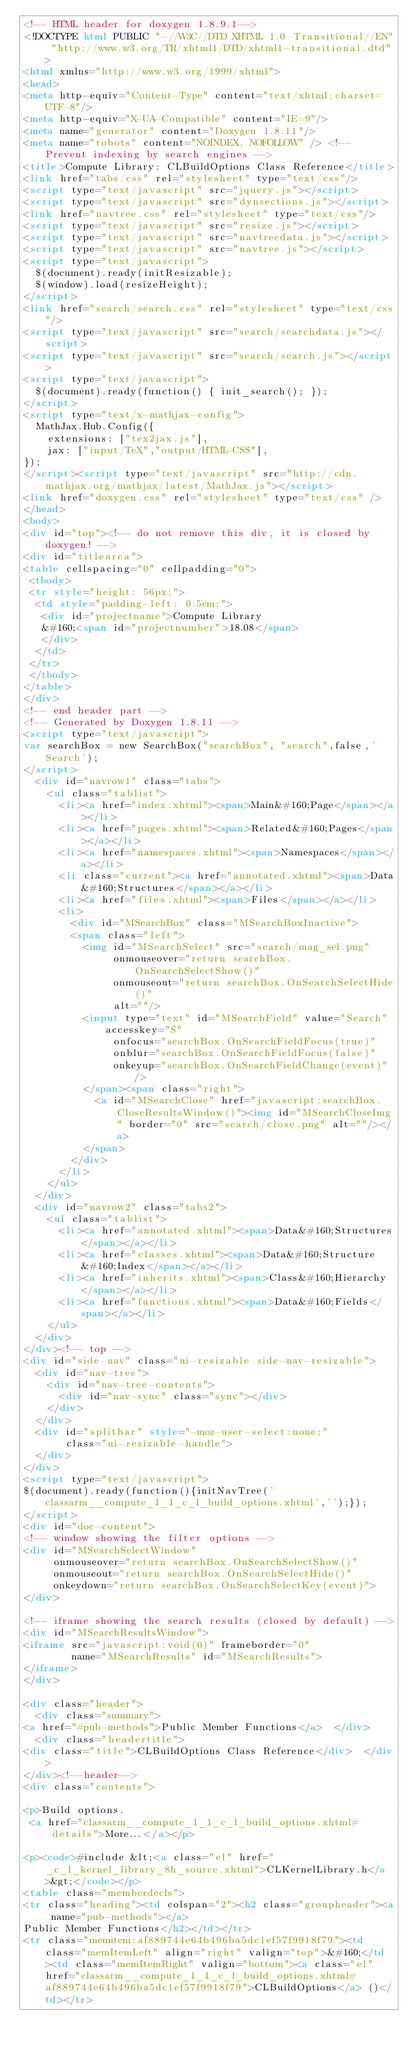Convert code to text. <code><loc_0><loc_0><loc_500><loc_500><_HTML_><!-- HTML header for doxygen 1.8.9.1-->
<!DOCTYPE html PUBLIC "-//W3C//DTD XHTML 1.0 Transitional//EN" "http://www.w3.org/TR/xhtml1/DTD/xhtml1-transitional.dtd">
<html xmlns="http://www.w3.org/1999/xhtml">
<head>
<meta http-equiv="Content-Type" content="text/xhtml;charset=UTF-8"/>
<meta http-equiv="X-UA-Compatible" content="IE=9"/>
<meta name="generator" content="Doxygen 1.8.11"/>
<meta name="robots" content="NOINDEX, NOFOLLOW" /> <!-- Prevent indexing by search engines -->
<title>Compute Library: CLBuildOptions Class Reference</title>
<link href="tabs.css" rel="stylesheet" type="text/css"/>
<script type="text/javascript" src="jquery.js"></script>
<script type="text/javascript" src="dynsections.js"></script>
<link href="navtree.css" rel="stylesheet" type="text/css"/>
<script type="text/javascript" src="resize.js"></script>
<script type="text/javascript" src="navtreedata.js"></script>
<script type="text/javascript" src="navtree.js"></script>
<script type="text/javascript">
  $(document).ready(initResizable);
  $(window).load(resizeHeight);
</script>
<link href="search/search.css" rel="stylesheet" type="text/css"/>
<script type="text/javascript" src="search/searchdata.js"></script>
<script type="text/javascript" src="search/search.js"></script>
<script type="text/javascript">
  $(document).ready(function() { init_search(); });
</script>
<script type="text/x-mathjax-config">
  MathJax.Hub.Config({
    extensions: ["tex2jax.js"],
    jax: ["input/TeX","output/HTML-CSS"],
});
</script><script type="text/javascript" src="http://cdn.mathjax.org/mathjax/latest/MathJax.js"></script>
<link href="doxygen.css" rel="stylesheet" type="text/css" />
</head>
<body>
<div id="top"><!-- do not remove this div, it is closed by doxygen! -->
<div id="titlearea">
<table cellspacing="0" cellpadding="0">
 <tbody>
 <tr style="height: 56px;">
  <td style="padding-left: 0.5em;">
   <div id="projectname">Compute Library
   &#160;<span id="projectnumber">18.08</span>
   </div>
  </td>
 </tr>
 </tbody>
</table>
</div>
<!-- end header part -->
<!-- Generated by Doxygen 1.8.11 -->
<script type="text/javascript">
var searchBox = new SearchBox("searchBox", "search",false,'Search');
</script>
  <div id="navrow1" class="tabs">
    <ul class="tablist">
      <li><a href="index.xhtml"><span>Main&#160;Page</span></a></li>
      <li><a href="pages.xhtml"><span>Related&#160;Pages</span></a></li>
      <li><a href="namespaces.xhtml"><span>Namespaces</span></a></li>
      <li class="current"><a href="annotated.xhtml"><span>Data&#160;Structures</span></a></li>
      <li><a href="files.xhtml"><span>Files</span></a></li>
      <li>
        <div id="MSearchBox" class="MSearchBoxInactive">
        <span class="left">
          <img id="MSearchSelect" src="search/mag_sel.png"
               onmouseover="return searchBox.OnSearchSelectShow()"
               onmouseout="return searchBox.OnSearchSelectHide()"
               alt=""/>
          <input type="text" id="MSearchField" value="Search" accesskey="S"
               onfocus="searchBox.OnSearchFieldFocus(true)" 
               onblur="searchBox.OnSearchFieldFocus(false)" 
               onkeyup="searchBox.OnSearchFieldChange(event)"/>
          </span><span class="right">
            <a id="MSearchClose" href="javascript:searchBox.CloseResultsWindow()"><img id="MSearchCloseImg" border="0" src="search/close.png" alt=""/></a>
          </span>
        </div>
      </li>
    </ul>
  </div>
  <div id="navrow2" class="tabs2">
    <ul class="tablist">
      <li><a href="annotated.xhtml"><span>Data&#160;Structures</span></a></li>
      <li><a href="classes.xhtml"><span>Data&#160;Structure&#160;Index</span></a></li>
      <li><a href="inherits.xhtml"><span>Class&#160;Hierarchy</span></a></li>
      <li><a href="functions.xhtml"><span>Data&#160;Fields</span></a></li>
    </ul>
  </div>
</div><!-- top -->
<div id="side-nav" class="ui-resizable side-nav-resizable">
  <div id="nav-tree">
    <div id="nav-tree-contents">
      <div id="nav-sync" class="sync"></div>
    </div>
  </div>
  <div id="splitbar" style="-moz-user-select:none;" 
       class="ui-resizable-handle">
  </div>
</div>
<script type="text/javascript">
$(document).ready(function(){initNavTree('classarm__compute_1_1_c_l_build_options.xhtml','');});
</script>
<div id="doc-content">
<!-- window showing the filter options -->
<div id="MSearchSelectWindow"
     onmouseover="return searchBox.OnSearchSelectShow()"
     onmouseout="return searchBox.OnSearchSelectHide()"
     onkeydown="return searchBox.OnSearchSelectKey(event)">
</div>

<!-- iframe showing the search results (closed by default) -->
<div id="MSearchResultsWindow">
<iframe src="javascript:void(0)" frameborder="0" 
        name="MSearchResults" id="MSearchResults">
</iframe>
</div>

<div class="header">
  <div class="summary">
<a href="#pub-methods">Public Member Functions</a>  </div>
  <div class="headertitle">
<div class="title">CLBuildOptions Class Reference</div>  </div>
</div><!--header-->
<div class="contents">

<p>Build options.  
 <a href="classarm__compute_1_1_c_l_build_options.xhtml#details">More...</a></p>

<p><code>#include &lt;<a class="el" href="_c_l_kernel_library_8h_source.xhtml">CLKernelLibrary.h</a>&gt;</code></p>
<table class="memberdecls">
<tr class="heading"><td colspan="2"><h2 class="groupheader"><a name="pub-methods"></a>
Public Member Functions</h2></td></tr>
<tr class="memitem:af889744e64b496ba5dc1ef57f9918f79"><td class="memItemLeft" align="right" valign="top">&#160;</td><td class="memItemRight" valign="bottom"><a class="el" href="classarm__compute_1_1_c_l_build_options.xhtml#af889744e64b496ba5dc1ef57f9918f79">CLBuildOptions</a> ()</td></tr></code> 